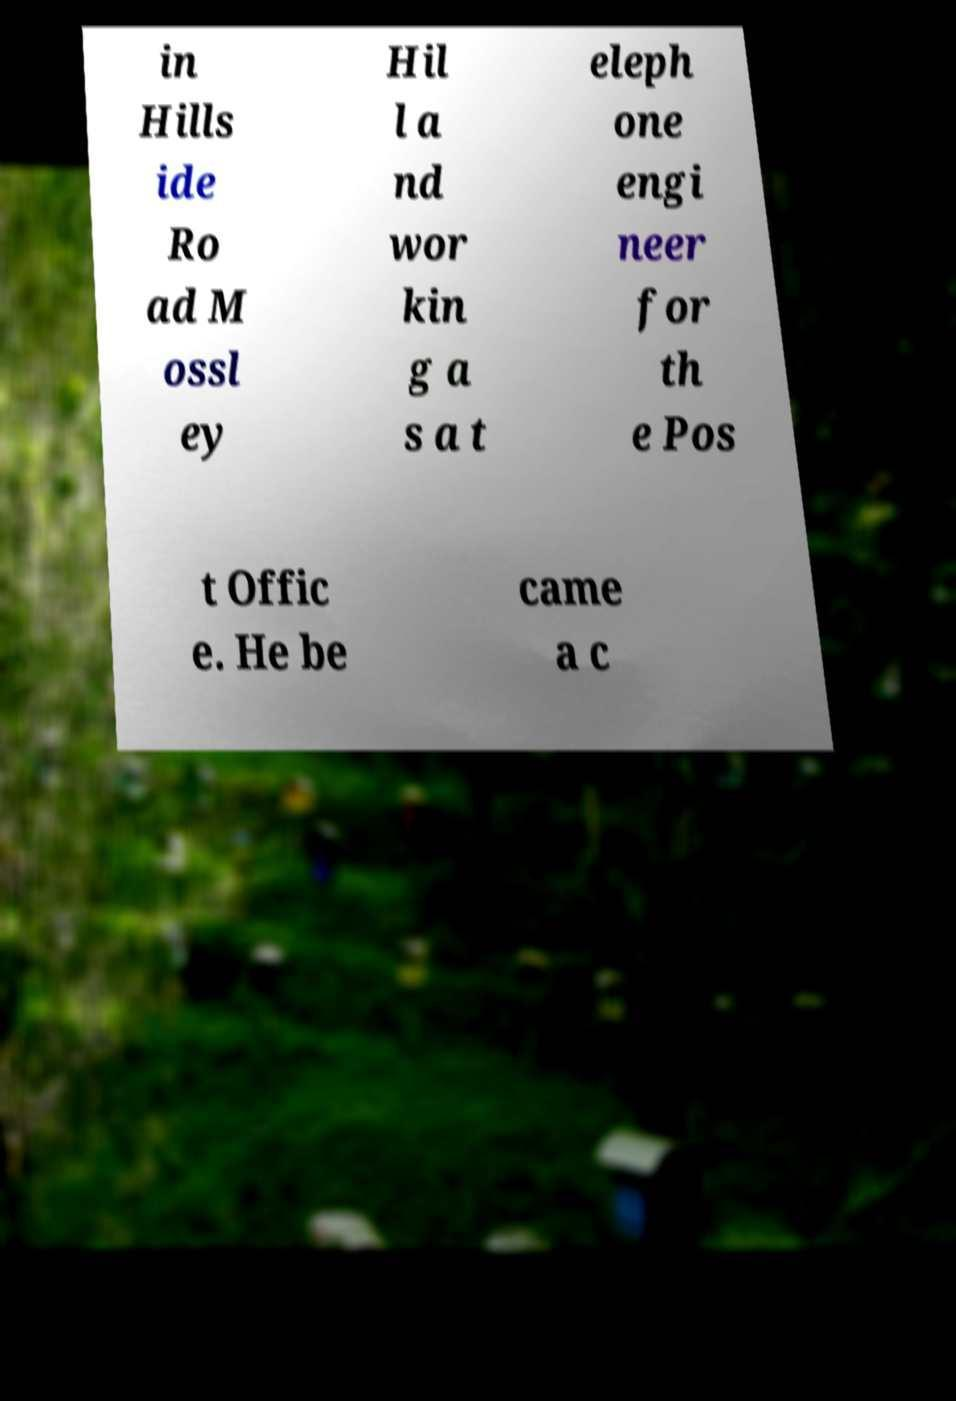Can you accurately transcribe the text from the provided image for me? in Hills ide Ro ad M ossl ey Hil l a nd wor kin g a s a t eleph one engi neer for th e Pos t Offic e. He be came a c 